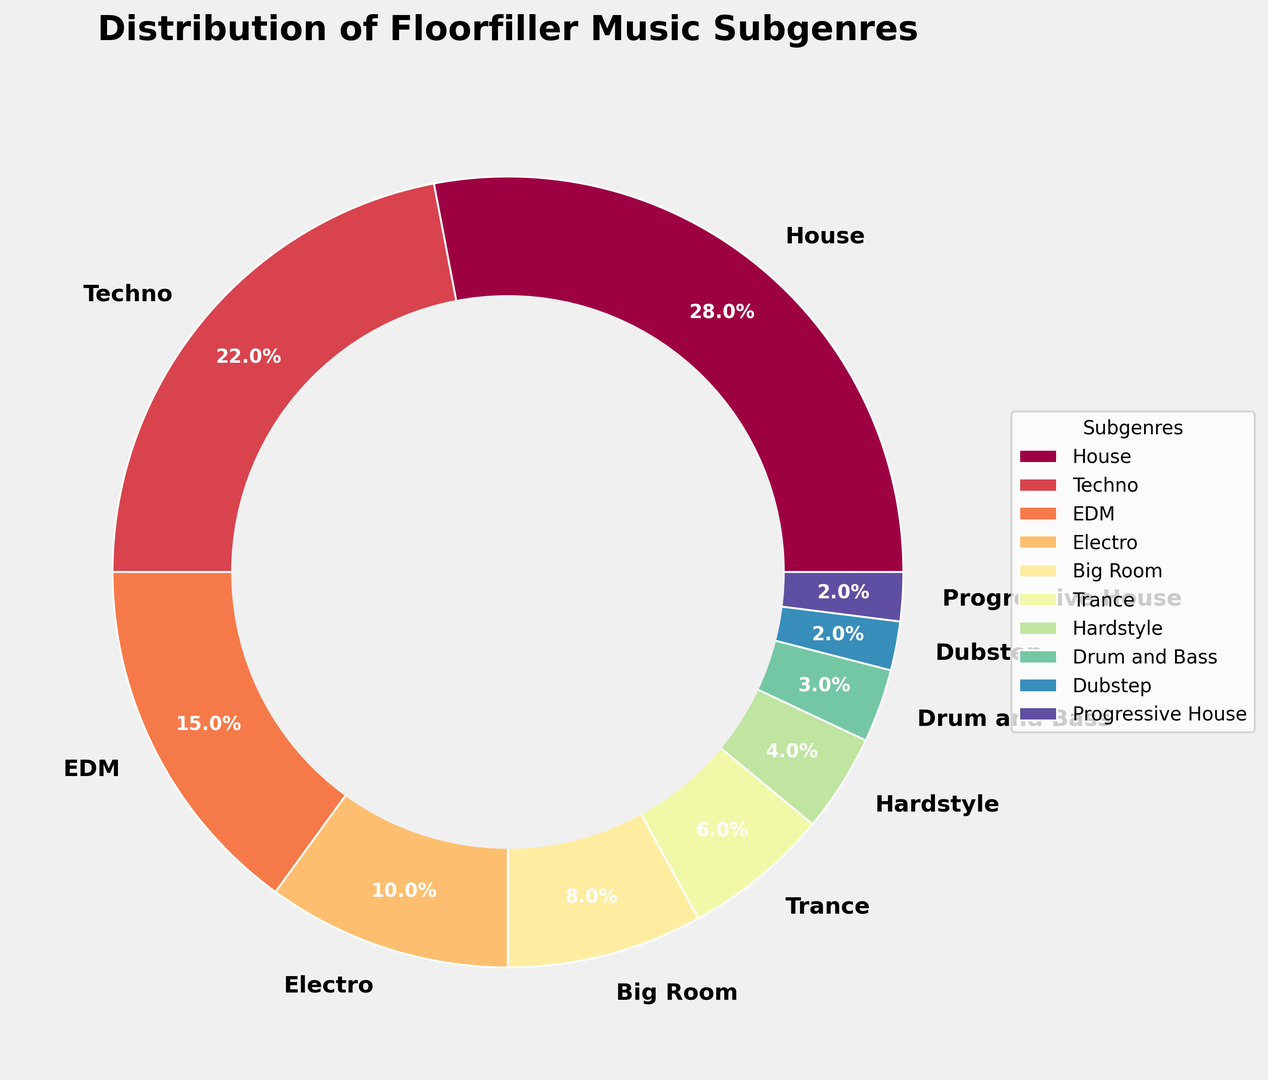What is the most dominant subgenre in Floorfiller music based on the chart? The subgenre with the largest percentage on the ring chart is the most dominant. From the chart, House occupies the largest section.
Answer: House How much more popular is House compared to Techno? To determine the difference in popularity, subtract Techno’s percentage from House’s percentage. House is 28% and Techno is 22%. So, 28% - 22% = 6%.
Answer: 6% What percentage of Floorfiller music is categorized as EDM and Electro combined? Combine the percentages for EDM and Electro. EDM is 15% and Electro is 10%, so 15% + 10% = 25%.
Answer: 25% How does the percentage of Drum and Bass compare to Dubstep? Compare the percentages directly. Drum and Bass is 3% while Dubstep is 2%. Therefore, Drum and Bass has a higher percentage.
Answer: Drum and Bass Which subgenre forms a smaller percentage, Trance or Progressive House? Compare the percentages directly. Trance is 6% while Progressive House is 2%. Therefore, Progressive House is smaller.
Answer: Progressive House What’s the total percentage accounted for by the three least represented subgenres? Add the percentages of Hardstyle, Drum and Bass, and Dubstep. 4% (Hardstyle) + 3% (Drum and Bass) + 2% (Dubstep) = 9%.
Answer: 9% If you combine the shares of Big Room and Trance, do they exceed the percentage of Techno? Combine the percentages for Big Room (8%) and Trance (6%). Check if the sum exceeds Techno's 22%. 8% + 6% = 14%, which is less than 22%.
Answer: No Which subgenres occupy less than 5% each? Identify subgenres with percentages less than 5%. Hardstyle (4%), Drum and Bass (3%), Dubstep (2%), and Progressive House (2%) fit this criterion.
Answer: Hardstyle, Drum and Bass, Dubstep, Progressive House What colors represent the highest and lowest percentages on the ring chart? The slice with the largest area (House, 28%) usually starts with the first color of the palette, while the smallest slice (Progressive House and Dubstep, 2% each) would generally be the last color. The exact colors would depend on the palette used, typically a spectral gradient, but implying the highest and lowest on the gradient scale.
Answer: Highest (House): Probably the start of the gradient (e.g., red); Lowest (Progressive House, Dubstep): Likely the end of the gradient (e.g., purple) 